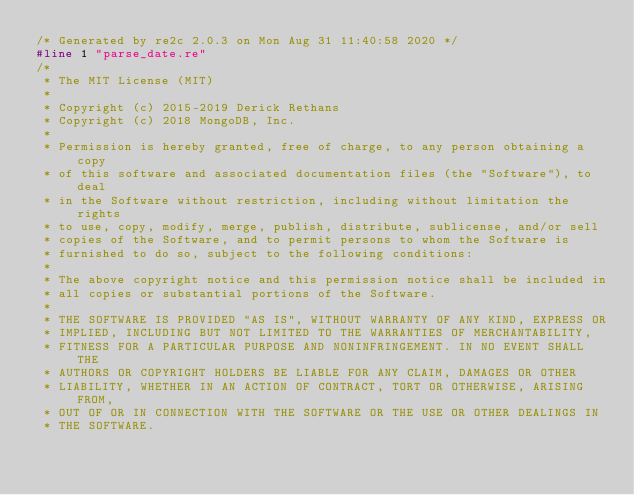<code> <loc_0><loc_0><loc_500><loc_500><_C_>/* Generated by re2c 2.0.3 on Mon Aug 31 11:40:58 2020 */
#line 1 "parse_date.re"
/*
 * The MIT License (MIT)
 *
 * Copyright (c) 2015-2019 Derick Rethans
 * Copyright (c) 2018 MongoDB, Inc.
 *
 * Permission is hereby granted, free of charge, to any person obtaining a copy
 * of this software and associated documentation files (the "Software"), to deal
 * in the Software without restriction, including without limitation the rights
 * to use, copy, modify, merge, publish, distribute, sublicense, and/or sell
 * copies of the Software, and to permit persons to whom the Software is
 * furnished to do so, subject to the following conditions:
 *
 * The above copyright notice and this permission notice shall be included in
 * all copies or substantial portions of the Software.
 *
 * THE SOFTWARE IS PROVIDED "AS IS", WITHOUT WARRANTY OF ANY KIND, EXPRESS OR
 * IMPLIED, INCLUDING BUT NOT LIMITED TO THE WARRANTIES OF MERCHANTABILITY,
 * FITNESS FOR A PARTICULAR PURPOSE AND NONINFRINGEMENT. IN NO EVENT SHALL THE
 * AUTHORS OR COPYRIGHT HOLDERS BE LIABLE FOR ANY CLAIM, DAMAGES OR OTHER
 * LIABILITY, WHETHER IN AN ACTION OF CONTRACT, TORT OR OTHERWISE, ARISING FROM,
 * OUT OF OR IN CONNECTION WITH THE SOFTWARE OR THE USE OR OTHER DEALINGS IN
 * THE SOFTWARE.</code> 